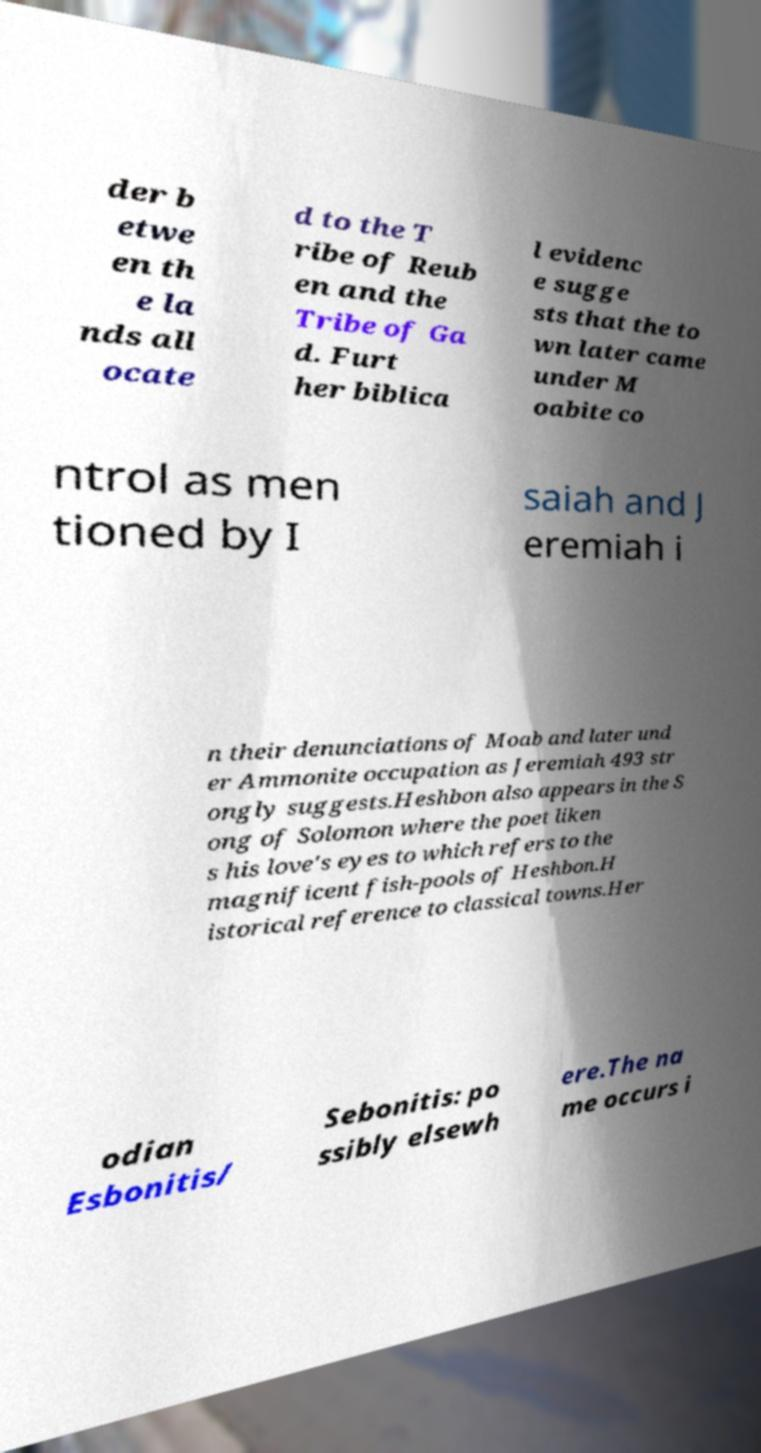There's text embedded in this image that I need extracted. Can you transcribe it verbatim? der b etwe en th e la nds all ocate d to the T ribe of Reub en and the Tribe of Ga d. Furt her biblica l evidenc e sugge sts that the to wn later came under M oabite co ntrol as men tioned by I saiah and J eremiah i n their denunciations of Moab and later und er Ammonite occupation as Jeremiah 493 str ongly suggests.Heshbon also appears in the S ong of Solomon where the poet liken s his love's eyes to which refers to the magnificent fish-pools of Heshbon.H istorical reference to classical towns.Her odian Esbonitis/ Sebonitis: po ssibly elsewh ere.The na me occurs i 